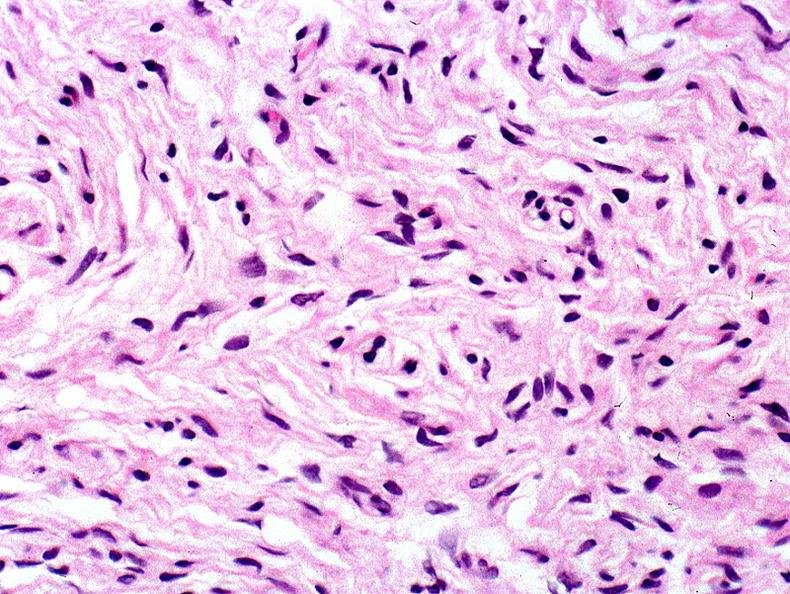does this image show skin, neurofibromatosis?
Answer the question using a single word or phrase. Yes 